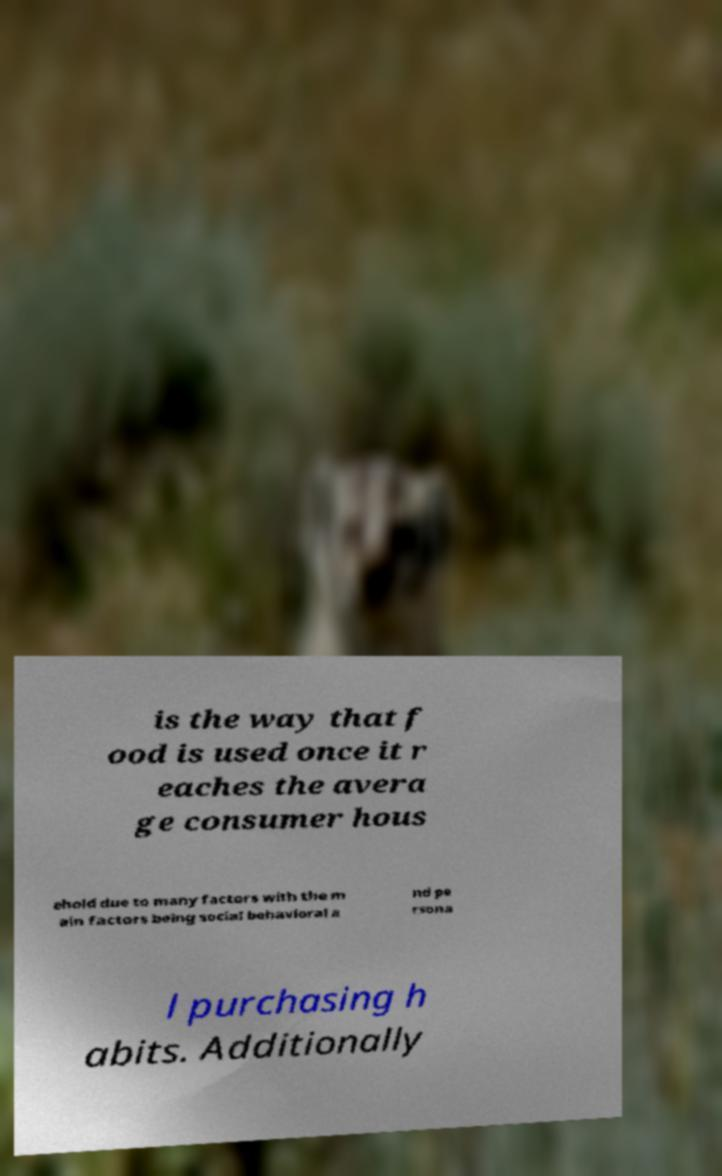Can you read and provide the text displayed in the image?This photo seems to have some interesting text. Can you extract and type it out for me? is the way that f ood is used once it r eaches the avera ge consumer hous ehold due to many factors with the m ain factors being social behavioral a nd pe rsona l purchasing h abits. Additionally 